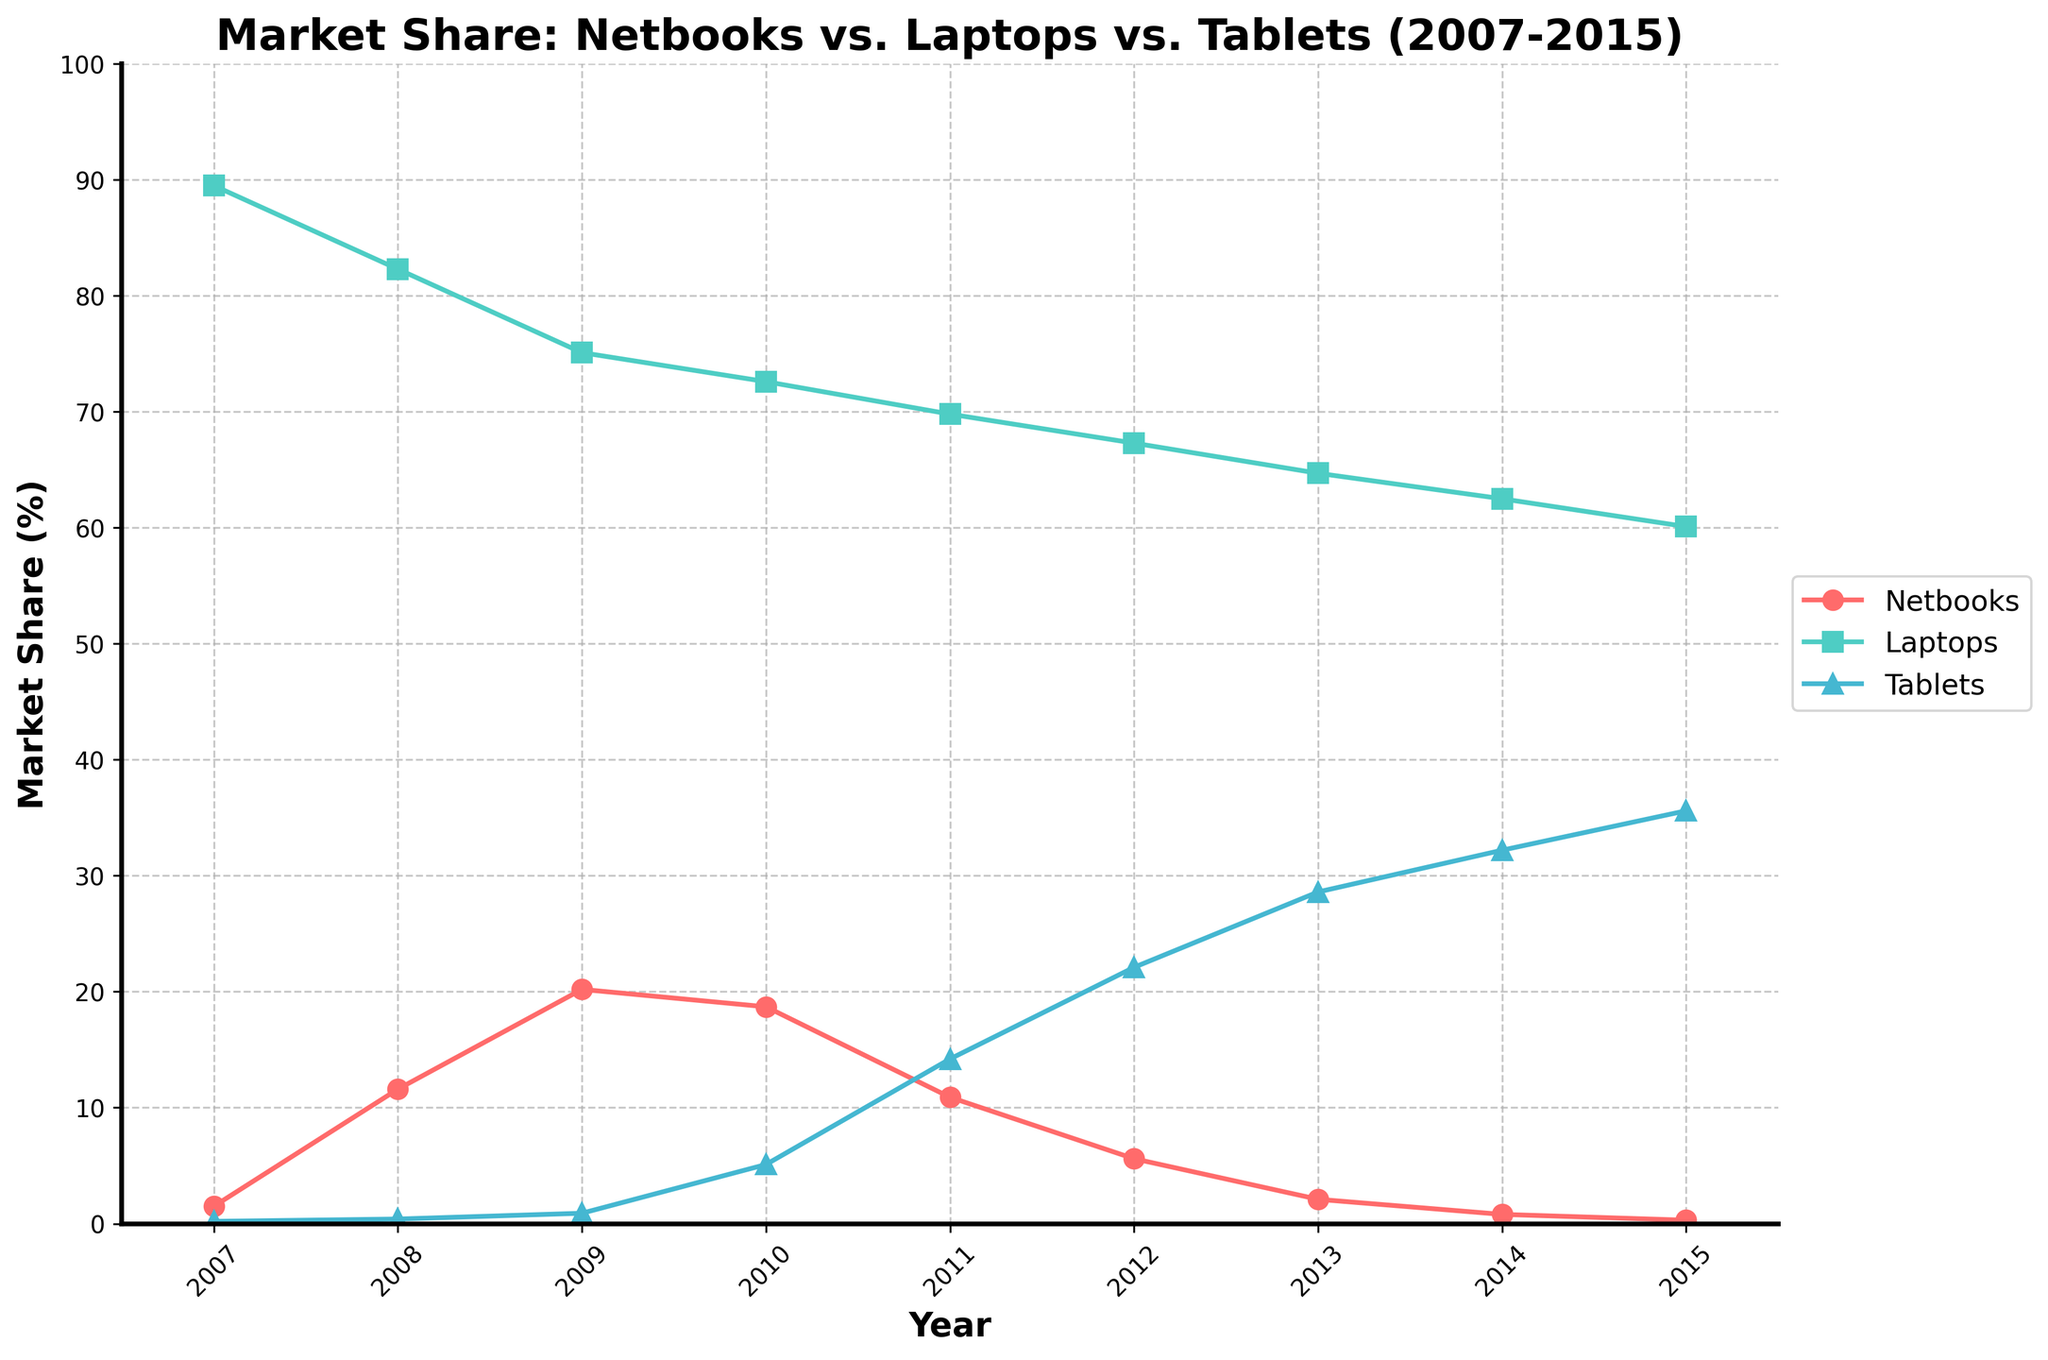What year did netbooks have the highest market share? The highest market share for netbooks is observed at the peak point in the line corresponding to netbooks in the year 2009.
Answer: 2009 Which device category had the highest market share in 2015? By observing the lines at the year 2015, the line for laptops is the highest among netbooks, laptops, and tablets.
Answer: Laptops How did the market share of tablets change from 2007 to 2015? The market share of tablets increased from 0.2% in 2007 to 35.6% in 2015.
Answer: It increased Between which two consecutive years did netbooks experience the steepest decline in market share? The steepest decline for netbooks can be seen between 2010 and 2011, where the market share dropped from 18.7% to 10.9%.
Answer: 2010 to 2011 What was the combined market share of netbooks and tablets in 2011? The market share for netbooks in 2011 was 10.9%, and for tablets, it was 14.2%. So, the combined share is 10.9% + 14.2% = 25.1%.
Answer: 25.1% In which year did tablets surpass netbooks in market share? By comparing the points in the lines for netbooks and tablets, tablets surpassed netbooks in 2011.
Answer: 2011 How did the market share of laptops evolve from 2007 to 2015? The market share of laptops decreased steadily from 89.5% in 2007 to 60.1% in 2015.
Answer: It decreased By how much did the market share of netbooks decrease between 2009 and 2015? The market share of netbooks in 2009 was 20.2%, and in 2015 it was 0.3%. The decrease is 20.2% - 0.3% = 19.9%.
Answer: 19.9% Which year saw the highest combined market share of laptops and tablets? By summing the market shares year by year, the highest combined share is in 2007: 89.5% (laptops) + 0.2% (tablets) = 89.7%.
Answer: 2007 